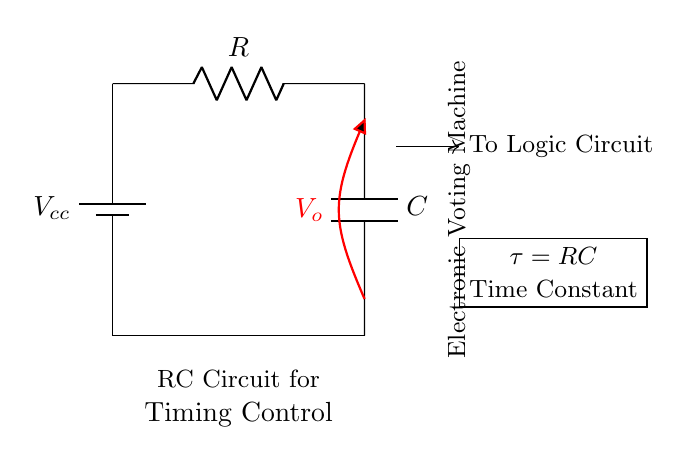What is the main function of the capacitor in this circuit? The capacitor temporarily stores electrical energy and releases it, helping to control the timing of signals in the circuit.
Answer: timing control What is the time constant of this RC circuit? The time constant, represented as tau, is calculated by multiplying the resistance (R) and capacitance (C). It indicates how quickly the circuit responds to changes in voltage.
Answer: RC What components are present in this diagram? The circuit includes a resistor, capacitor, and a voltage source (battery). These are essential for creating an RC timing circuit.
Answer: resistor, capacitor, battery What does the voltage labeled V_o represent? V_o is the output voltage across the capacitor, which changes as the capacitor charges and discharges, reflecting the current state of the circuit.
Answer: output voltage What direction is the current flowing in the circuit? The current flows from the positive terminal of the battery, through the resistor and capacitor, and back to the negative terminal of the battery, creating a closed loop.
Answer: clockwise How does increasing the resistance (R) affect the time constant (tau)? Increasing the resistance raises the time constant, leading to slower charging and discharging of the capacitor, which delays the timing in the circuit.
Answer: increases 